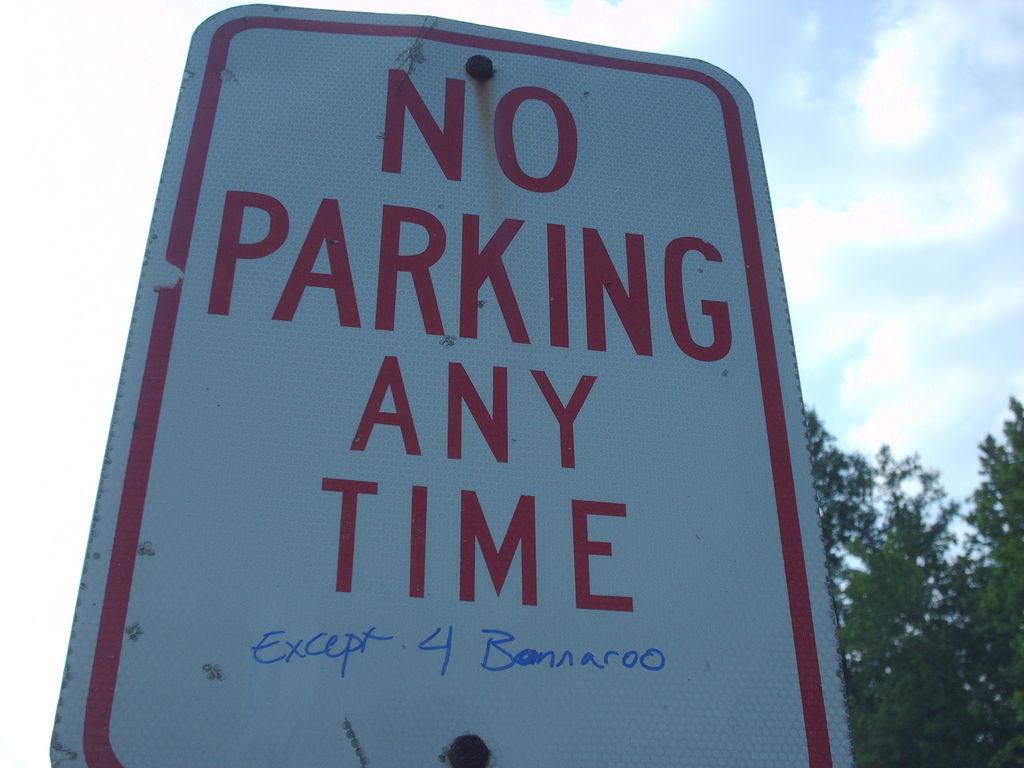What is written in blue ink on the sign?
Your answer should be compact. Except 4 bonnaroo. 